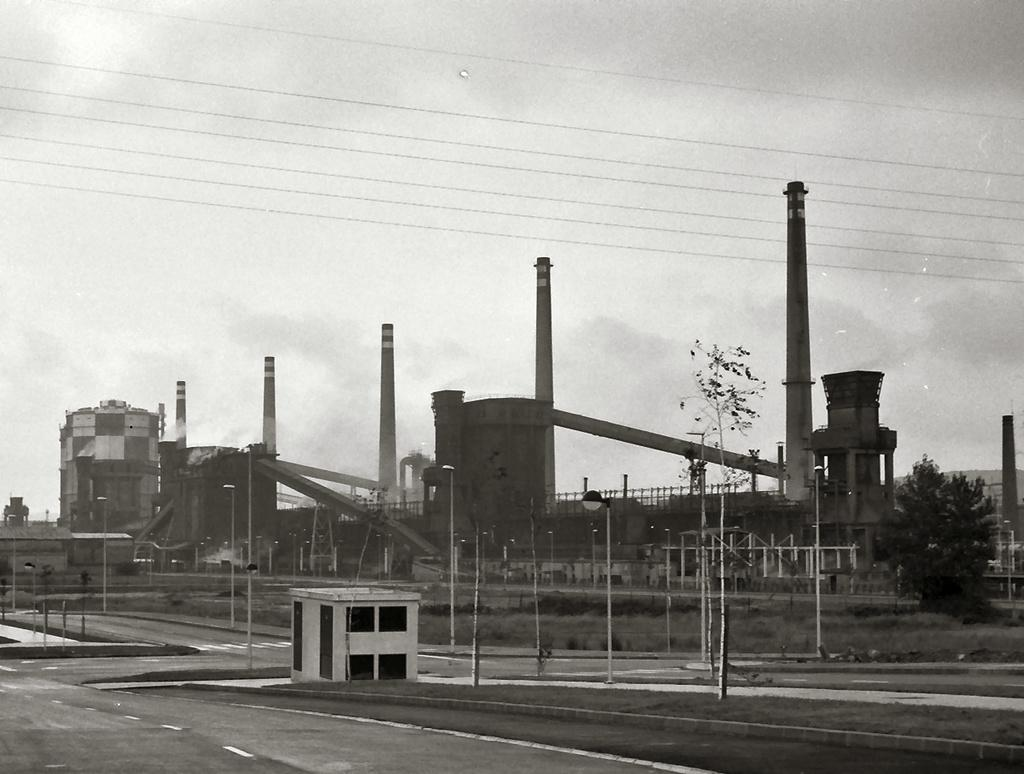What type of structures can be seen in the image? There are buildings in the image. What are the vertical objects in the image? There are poles in the image. What type of vegetation is present in the image? There are trees in the image. What are the tall, smoke-emitting structures in the image? There are chimneys in the image. What is the ground surface like in the image? The ground with grass is visible in the image. What objects can be found on the ground in the image? There are objects on the ground in the image. What type of barrier is present in the image? There is a fence in the image. What is visible in the upper part of the image? The sky is visible in the image. What can be seen in the sky in the image? There are clouds in the sky in the image. Reasoning: Let' Let's think step by step in order to produce the conversation. We start by identifying the main subjects and objects in the image based on the provided facts. We then formulate questions that focus on the location and characteristics of these subjects and objects, ensuring that each question can be answered definitively with the information given. We avoid yes/no questions and ensure that the language is simple and clear. Absurd Question/Answer: How many rabbits are hopping in the middle of the image? There are no rabbits present in the image. What type of glue is being used to hold the clouds together in the image? There is no glue present in the image; the clouds are naturally occurring in the sky. How many rabbits are hopping in the middle of the image? There are no rabbits present in the image. What type of glue is being used to hold the clouds together in the image? There is no glue present in the image; the clouds are naturally occurring in the sky. 